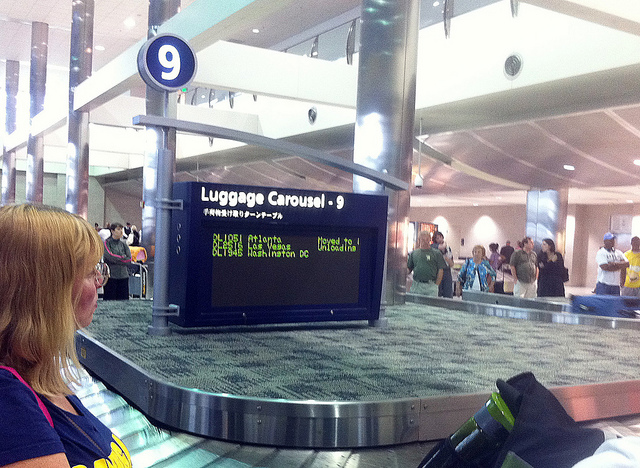Please transcribe the text information in this image. 9 Luggage Carousel 9 unloading Moved DC Atlanta 